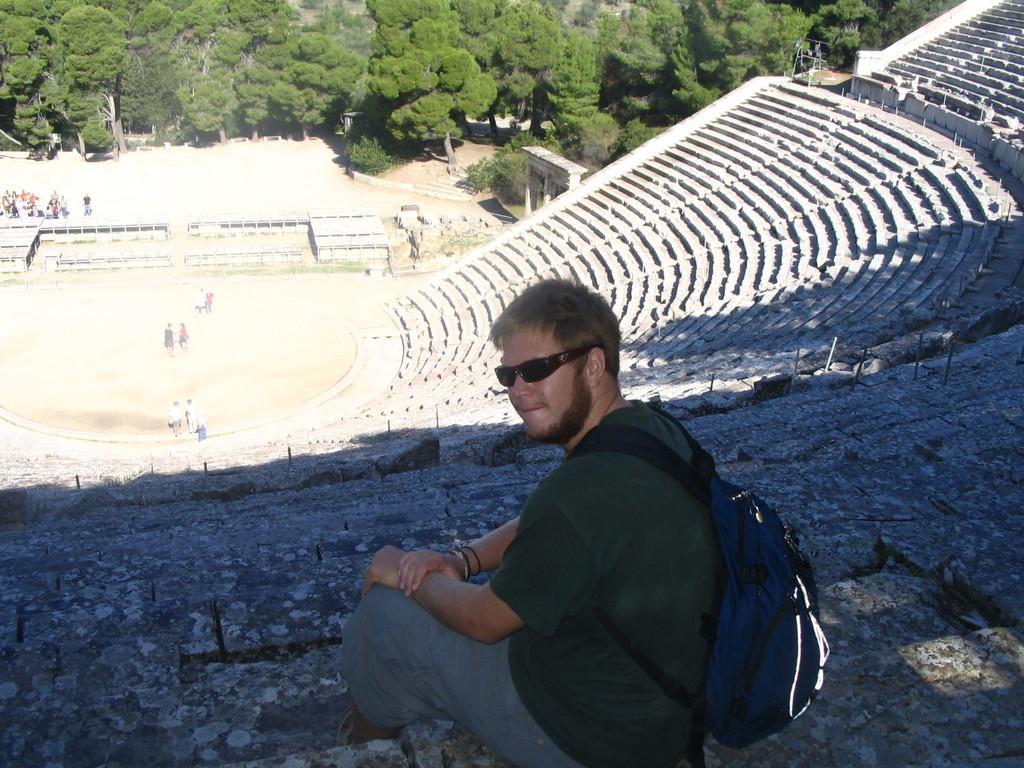Can you describe this image briefly? In this image we can see a person sitting on the surface. We can also see the staircase, some poles, a group of people standing on the ground, the buildings, grass and a group of trees. 